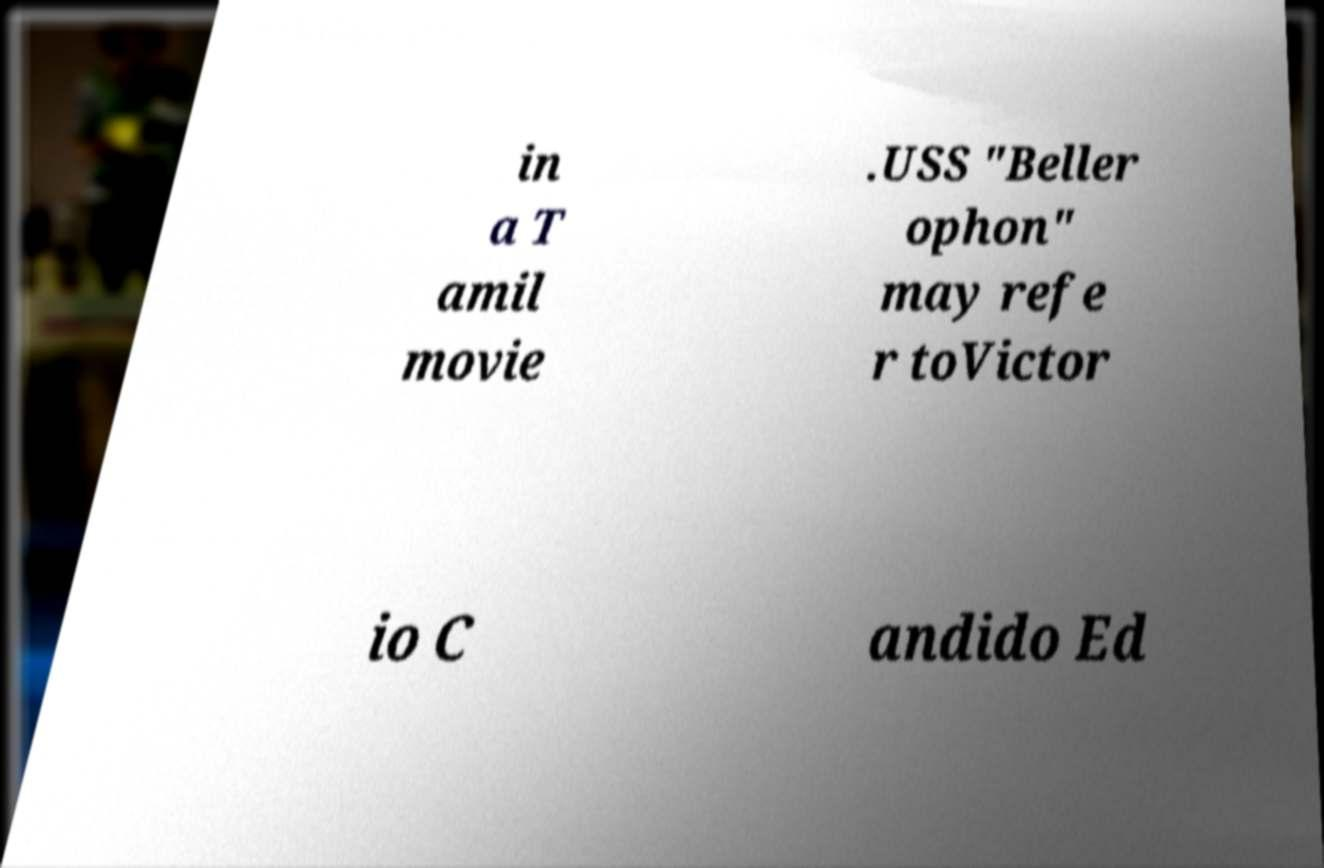For documentation purposes, I need the text within this image transcribed. Could you provide that? in a T amil movie .USS "Beller ophon" may refe r toVictor io C andido Ed 